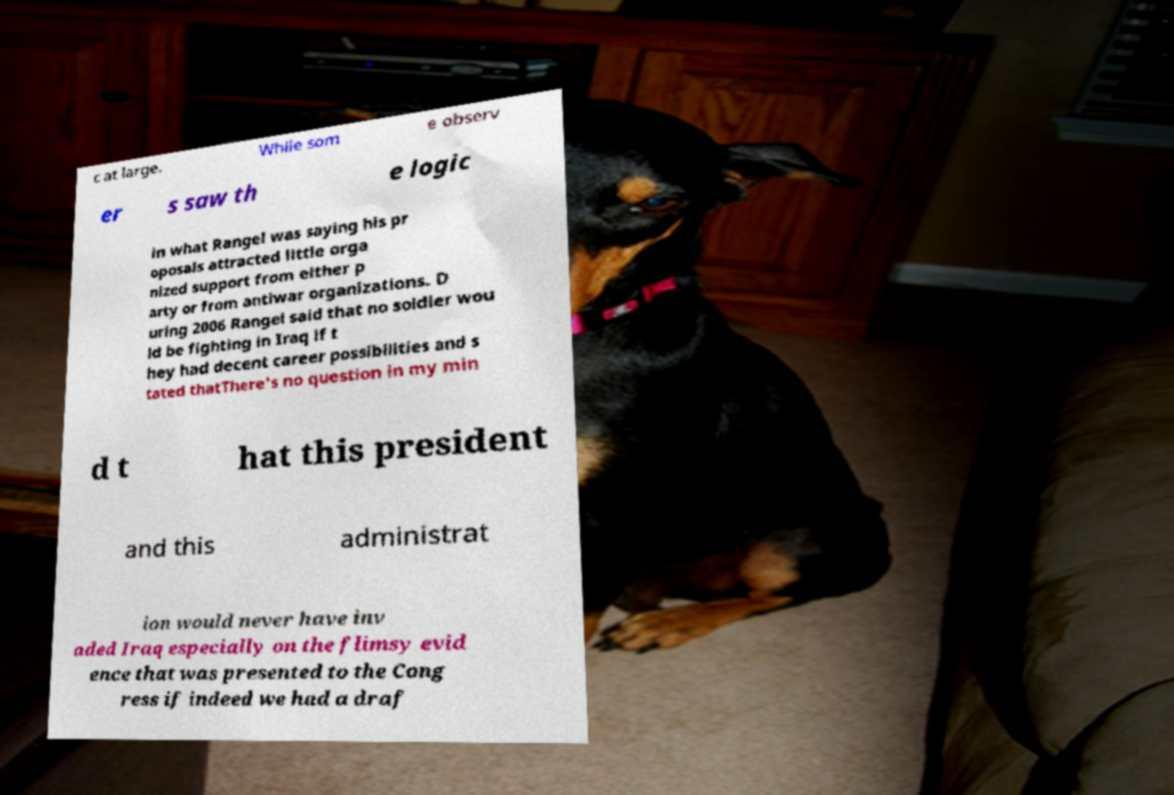Please identify and transcribe the text found in this image. c at large. While som e observ er s saw th e logic in what Rangel was saying his pr oposals attracted little orga nized support from either p arty or from antiwar organizations. D uring 2006 Rangel said that no soldier wou ld be fighting in Iraq if t hey had decent career possibilities and s tated thatThere's no question in my min d t hat this president and this administrat ion would never have inv aded Iraq especially on the flimsy evid ence that was presented to the Cong ress if indeed we had a draf 